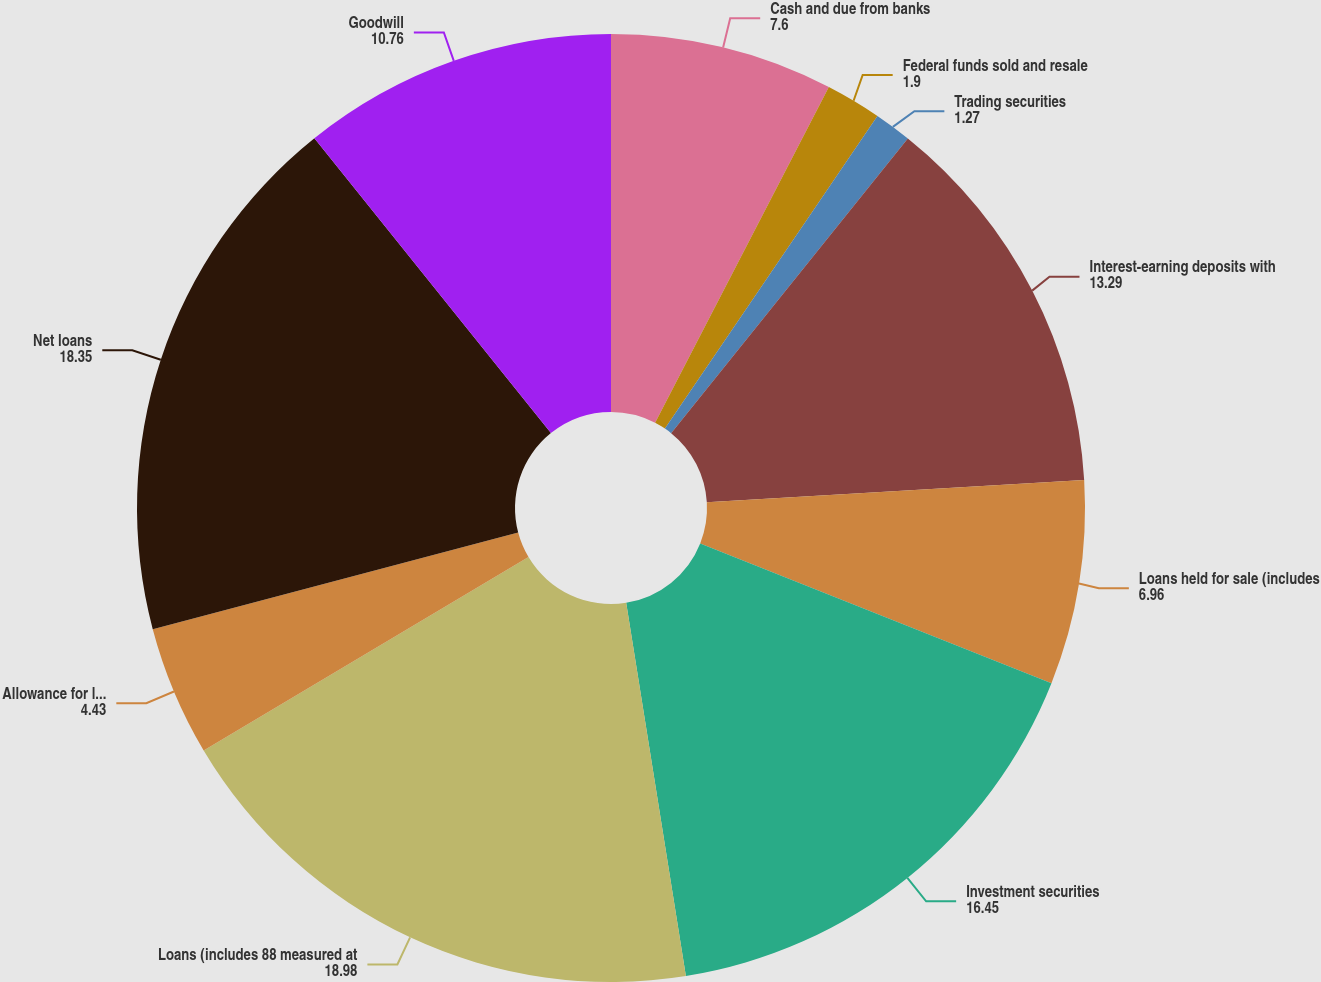<chart> <loc_0><loc_0><loc_500><loc_500><pie_chart><fcel>Cash and due from banks<fcel>Federal funds sold and resale<fcel>Trading securities<fcel>Interest-earning deposits with<fcel>Loans held for sale (includes<fcel>Investment securities<fcel>Loans (includes 88 measured at<fcel>Allowance for loan and lease<fcel>Net loans<fcel>Goodwill<nl><fcel>7.6%<fcel>1.9%<fcel>1.27%<fcel>13.29%<fcel>6.96%<fcel>16.45%<fcel>18.98%<fcel>4.43%<fcel>18.35%<fcel>10.76%<nl></chart> 